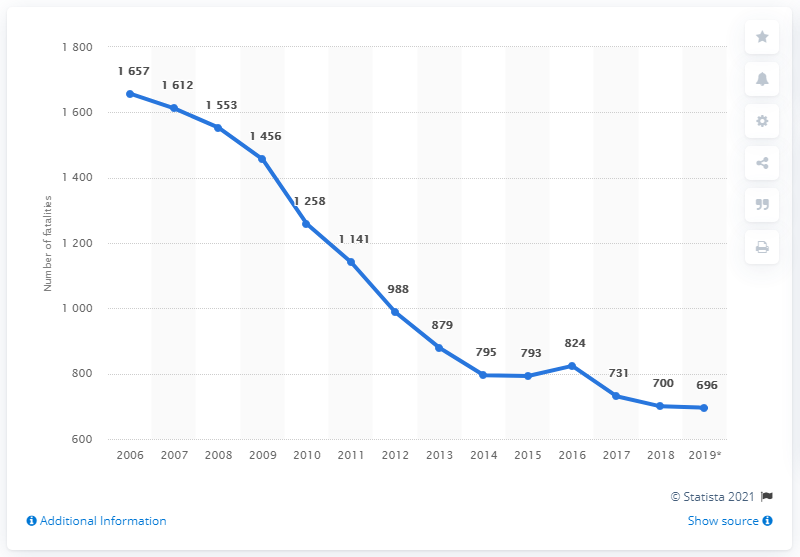In what year did the highest number of road fatalities occur? The year with the highest number of road fatalities, as depicted in the chart, was 2006, with a total of 1,657 fatalities. It's noticeable that there has been a general downward trend in road fatalities since then, which can be attributed to a variety of factors such as improvements in vehicle safety, more stringent traffic laws, and better road infrastructure. 